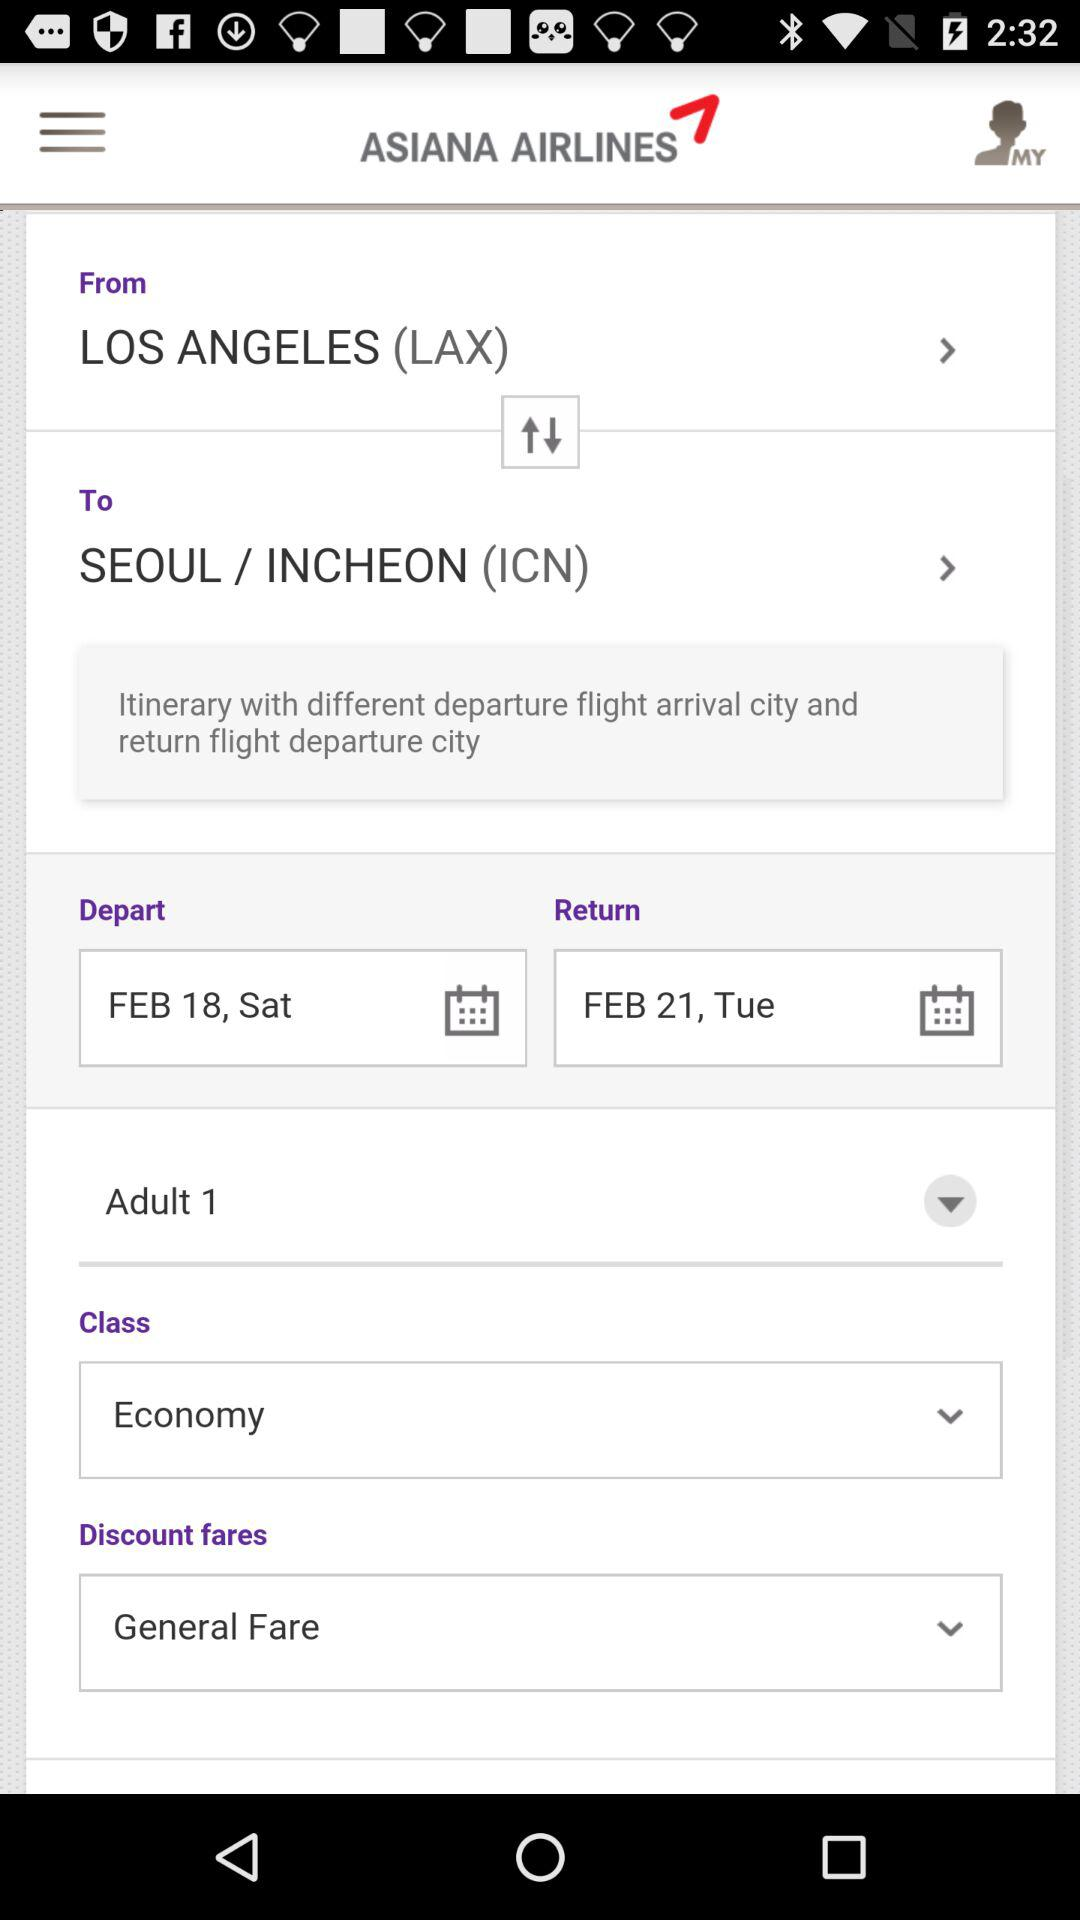How many adults are there? There is 1 adult. 